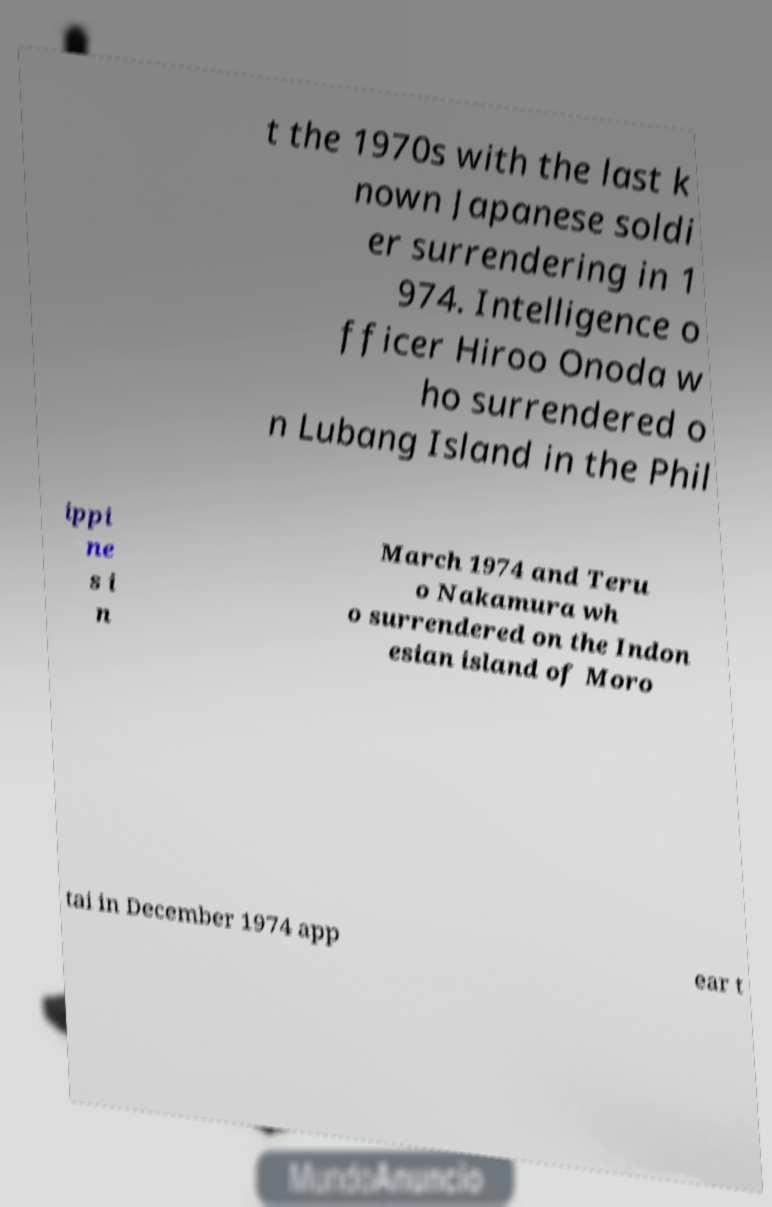Please read and relay the text visible in this image. What does it say? t the 1970s with the last k nown Japanese soldi er surrendering in 1 974. Intelligence o fficer Hiroo Onoda w ho surrendered o n Lubang Island in the Phil ippi ne s i n March 1974 and Teru o Nakamura wh o surrendered on the Indon esian island of Moro tai in December 1974 app ear t 